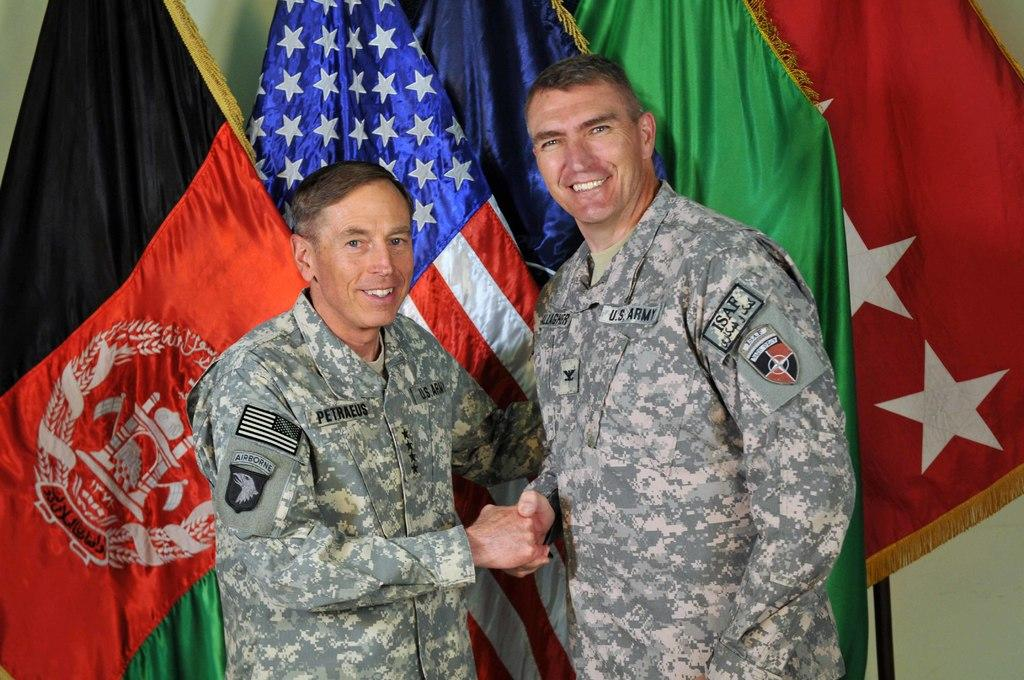What are the people in the image doing? The people in the image are shaking their hands. What else can be seen in the image besides the people? There are flags in the image. What is visible in the background of the image? There is a wall in the background of the image. What type of tin can be seen on the wall in the image? There is no tin present on the wall in the image. Where is the best spot to take a picture of the people shaking hands in the image? The facts provided do not give enough information to determine the best spot for taking a picture. 